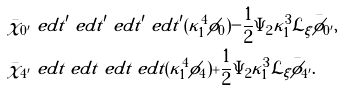<formula> <loc_0><loc_0><loc_500><loc_500>\bar { \chi } _ { 0 ^ { \prime } } & \ e d t ^ { \prime } \ e d t ^ { \prime } \ e d t ^ { \prime } \ e d t ^ { \prime } ( \kappa _ { 1 } ^ { 4 } \phi _ { 0 } ) - \frac { 1 } { 2 } \Psi _ { 2 } \kappa _ { 1 } ^ { 3 } \mathcal { L } _ { \xi } \bar { \phi } _ { 0 ^ { \prime } } , \\ \bar { \chi } _ { 4 ^ { \prime } } & \ e d t \ e d t \ e d t \ e d t ( \kappa _ { 1 } ^ { 4 } \phi _ { 4 } ) + \frac { 1 } { 2 } \Psi _ { 2 } \kappa _ { 1 } ^ { 3 } \mathcal { L } _ { \xi } \bar { \phi } _ { 4 ^ { \prime } } .</formula> 